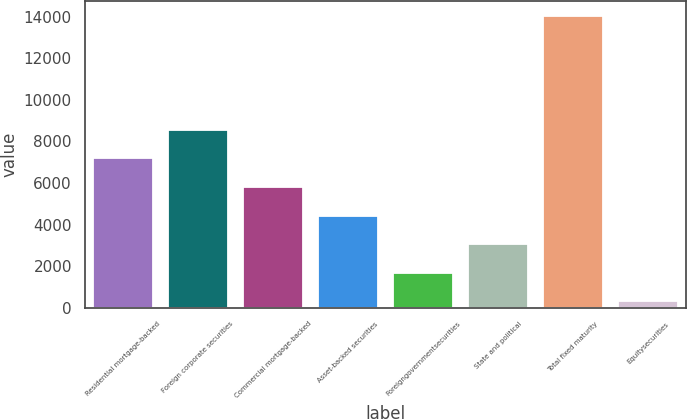Convert chart. <chart><loc_0><loc_0><loc_500><loc_500><bar_chart><fcel>Residential mortgage-backed<fcel>Foreign corporate securities<fcel>Commercial mortgage-backed<fcel>Asset-backed securities<fcel>Foreigngovernmentsecurities<fcel>State and political<fcel>Total fixed maturity<fcel>Equitysecurities<nl><fcel>7184<fcel>8559.6<fcel>5808.4<fcel>4432.8<fcel>1681.6<fcel>3057.2<fcel>14062<fcel>306<nl></chart> 